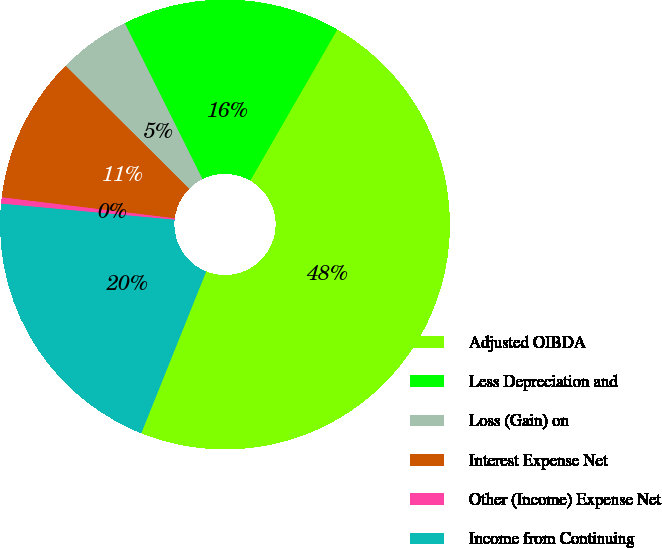<chart> <loc_0><loc_0><loc_500><loc_500><pie_chart><fcel>Adjusted OIBDA<fcel>Less Depreciation and<fcel>Loss (Gain) on<fcel>Interest Expense Net<fcel>Other (Income) Expense Net<fcel>Income from Continuing<nl><fcel>47.75%<fcel>15.67%<fcel>5.18%<fcel>10.54%<fcel>0.45%<fcel>20.4%<nl></chart> 